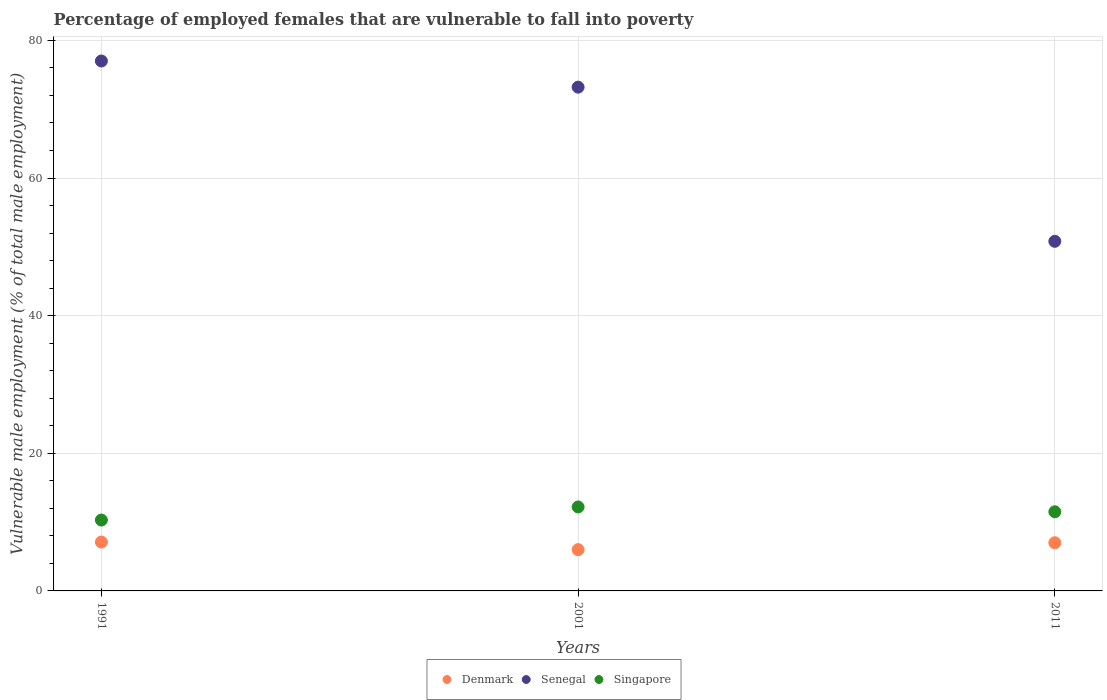Is the number of dotlines equal to the number of legend labels?
Offer a terse response. Yes. What is the percentage of employed females who are vulnerable to fall into poverty in Singapore in 1991?
Provide a succinct answer. 10.3. Across all years, what is the maximum percentage of employed females who are vulnerable to fall into poverty in Singapore?
Provide a short and direct response. 12.2. Across all years, what is the minimum percentage of employed females who are vulnerable to fall into poverty in Singapore?
Keep it short and to the point. 10.3. What is the difference between the percentage of employed females who are vulnerable to fall into poverty in Singapore in 1991 and that in 2011?
Keep it short and to the point. -1.2. What is the difference between the percentage of employed females who are vulnerable to fall into poverty in Senegal in 1991 and the percentage of employed females who are vulnerable to fall into poverty in Singapore in 2011?
Your answer should be compact. 65.5. What is the average percentage of employed females who are vulnerable to fall into poverty in Singapore per year?
Offer a very short reply. 11.33. In the year 2001, what is the difference between the percentage of employed females who are vulnerable to fall into poverty in Senegal and percentage of employed females who are vulnerable to fall into poverty in Denmark?
Offer a very short reply. 67.2. What is the ratio of the percentage of employed females who are vulnerable to fall into poverty in Senegal in 2001 to that in 2011?
Your response must be concise. 1.44. Is the percentage of employed females who are vulnerable to fall into poverty in Senegal in 1991 less than that in 2001?
Provide a short and direct response. No. What is the difference between the highest and the second highest percentage of employed females who are vulnerable to fall into poverty in Singapore?
Provide a short and direct response. 0.7. What is the difference between the highest and the lowest percentage of employed females who are vulnerable to fall into poverty in Denmark?
Your answer should be very brief. 1.1. In how many years, is the percentage of employed females who are vulnerable to fall into poverty in Denmark greater than the average percentage of employed females who are vulnerable to fall into poverty in Denmark taken over all years?
Offer a very short reply. 2. Is the sum of the percentage of employed females who are vulnerable to fall into poverty in Senegal in 2001 and 2011 greater than the maximum percentage of employed females who are vulnerable to fall into poverty in Denmark across all years?
Ensure brevity in your answer.  Yes. Is the percentage of employed females who are vulnerable to fall into poverty in Denmark strictly greater than the percentage of employed females who are vulnerable to fall into poverty in Senegal over the years?
Give a very brief answer. No. Is the percentage of employed females who are vulnerable to fall into poverty in Denmark strictly less than the percentage of employed females who are vulnerable to fall into poverty in Senegal over the years?
Your response must be concise. Yes. Does the graph contain any zero values?
Provide a short and direct response. No. Does the graph contain grids?
Offer a terse response. Yes. Where does the legend appear in the graph?
Your answer should be compact. Bottom center. How many legend labels are there?
Make the answer very short. 3. What is the title of the graph?
Keep it short and to the point. Percentage of employed females that are vulnerable to fall into poverty. What is the label or title of the Y-axis?
Ensure brevity in your answer.  Vulnerable male employment (% of total male employment). What is the Vulnerable male employment (% of total male employment) of Denmark in 1991?
Offer a terse response. 7.1. What is the Vulnerable male employment (% of total male employment) in Singapore in 1991?
Make the answer very short. 10.3. What is the Vulnerable male employment (% of total male employment) of Denmark in 2001?
Your response must be concise. 6. What is the Vulnerable male employment (% of total male employment) in Senegal in 2001?
Your answer should be compact. 73.2. What is the Vulnerable male employment (% of total male employment) of Singapore in 2001?
Provide a short and direct response. 12.2. What is the Vulnerable male employment (% of total male employment) of Denmark in 2011?
Keep it short and to the point. 7. What is the Vulnerable male employment (% of total male employment) of Senegal in 2011?
Ensure brevity in your answer.  50.8. Across all years, what is the maximum Vulnerable male employment (% of total male employment) in Denmark?
Provide a short and direct response. 7.1. Across all years, what is the maximum Vulnerable male employment (% of total male employment) in Singapore?
Provide a short and direct response. 12.2. Across all years, what is the minimum Vulnerable male employment (% of total male employment) of Senegal?
Your answer should be compact. 50.8. Across all years, what is the minimum Vulnerable male employment (% of total male employment) of Singapore?
Keep it short and to the point. 10.3. What is the total Vulnerable male employment (% of total male employment) of Denmark in the graph?
Make the answer very short. 20.1. What is the total Vulnerable male employment (% of total male employment) of Senegal in the graph?
Your answer should be very brief. 201. What is the total Vulnerable male employment (% of total male employment) of Singapore in the graph?
Ensure brevity in your answer.  34. What is the difference between the Vulnerable male employment (% of total male employment) in Denmark in 1991 and that in 2001?
Your answer should be compact. 1.1. What is the difference between the Vulnerable male employment (% of total male employment) of Senegal in 1991 and that in 2001?
Keep it short and to the point. 3.8. What is the difference between the Vulnerable male employment (% of total male employment) of Denmark in 1991 and that in 2011?
Provide a short and direct response. 0.1. What is the difference between the Vulnerable male employment (% of total male employment) of Senegal in 1991 and that in 2011?
Provide a succinct answer. 26.2. What is the difference between the Vulnerable male employment (% of total male employment) of Denmark in 2001 and that in 2011?
Your answer should be compact. -1. What is the difference between the Vulnerable male employment (% of total male employment) in Senegal in 2001 and that in 2011?
Offer a very short reply. 22.4. What is the difference between the Vulnerable male employment (% of total male employment) of Denmark in 1991 and the Vulnerable male employment (% of total male employment) of Senegal in 2001?
Provide a short and direct response. -66.1. What is the difference between the Vulnerable male employment (% of total male employment) of Senegal in 1991 and the Vulnerable male employment (% of total male employment) of Singapore in 2001?
Ensure brevity in your answer.  64.8. What is the difference between the Vulnerable male employment (% of total male employment) of Denmark in 1991 and the Vulnerable male employment (% of total male employment) of Senegal in 2011?
Your answer should be very brief. -43.7. What is the difference between the Vulnerable male employment (% of total male employment) of Denmark in 1991 and the Vulnerable male employment (% of total male employment) of Singapore in 2011?
Provide a short and direct response. -4.4. What is the difference between the Vulnerable male employment (% of total male employment) of Senegal in 1991 and the Vulnerable male employment (% of total male employment) of Singapore in 2011?
Keep it short and to the point. 65.5. What is the difference between the Vulnerable male employment (% of total male employment) in Denmark in 2001 and the Vulnerable male employment (% of total male employment) in Senegal in 2011?
Ensure brevity in your answer.  -44.8. What is the difference between the Vulnerable male employment (% of total male employment) of Denmark in 2001 and the Vulnerable male employment (% of total male employment) of Singapore in 2011?
Give a very brief answer. -5.5. What is the difference between the Vulnerable male employment (% of total male employment) of Senegal in 2001 and the Vulnerable male employment (% of total male employment) of Singapore in 2011?
Offer a very short reply. 61.7. What is the average Vulnerable male employment (% of total male employment) in Singapore per year?
Your answer should be compact. 11.33. In the year 1991, what is the difference between the Vulnerable male employment (% of total male employment) in Denmark and Vulnerable male employment (% of total male employment) in Senegal?
Your response must be concise. -69.9. In the year 1991, what is the difference between the Vulnerable male employment (% of total male employment) in Denmark and Vulnerable male employment (% of total male employment) in Singapore?
Keep it short and to the point. -3.2. In the year 1991, what is the difference between the Vulnerable male employment (% of total male employment) of Senegal and Vulnerable male employment (% of total male employment) of Singapore?
Make the answer very short. 66.7. In the year 2001, what is the difference between the Vulnerable male employment (% of total male employment) in Denmark and Vulnerable male employment (% of total male employment) in Senegal?
Your answer should be very brief. -67.2. In the year 2001, what is the difference between the Vulnerable male employment (% of total male employment) of Senegal and Vulnerable male employment (% of total male employment) of Singapore?
Make the answer very short. 61. In the year 2011, what is the difference between the Vulnerable male employment (% of total male employment) of Denmark and Vulnerable male employment (% of total male employment) of Senegal?
Give a very brief answer. -43.8. In the year 2011, what is the difference between the Vulnerable male employment (% of total male employment) in Denmark and Vulnerable male employment (% of total male employment) in Singapore?
Ensure brevity in your answer.  -4.5. In the year 2011, what is the difference between the Vulnerable male employment (% of total male employment) of Senegal and Vulnerable male employment (% of total male employment) of Singapore?
Offer a terse response. 39.3. What is the ratio of the Vulnerable male employment (% of total male employment) of Denmark in 1991 to that in 2001?
Provide a short and direct response. 1.18. What is the ratio of the Vulnerable male employment (% of total male employment) of Senegal in 1991 to that in 2001?
Give a very brief answer. 1.05. What is the ratio of the Vulnerable male employment (% of total male employment) in Singapore in 1991 to that in 2001?
Offer a terse response. 0.84. What is the ratio of the Vulnerable male employment (% of total male employment) of Denmark in 1991 to that in 2011?
Your response must be concise. 1.01. What is the ratio of the Vulnerable male employment (% of total male employment) in Senegal in 1991 to that in 2011?
Provide a short and direct response. 1.52. What is the ratio of the Vulnerable male employment (% of total male employment) of Singapore in 1991 to that in 2011?
Make the answer very short. 0.9. What is the ratio of the Vulnerable male employment (% of total male employment) of Denmark in 2001 to that in 2011?
Your answer should be compact. 0.86. What is the ratio of the Vulnerable male employment (% of total male employment) of Senegal in 2001 to that in 2011?
Make the answer very short. 1.44. What is the ratio of the Vulnerable male employment (% of total male employment) in Singapore in 2001 to that in 2011?
Keep it short and to the point. 1.06. What is the difference between the highest and the second highest Vulnerable male employment (% of total male employment) in Singapore?
Keep it short and to the point. 0.7. What is the difference between the highest and the lowest Vulnerable male employment (% of total male employment) of Senegal?
Give a very brief answer. 26.2. 